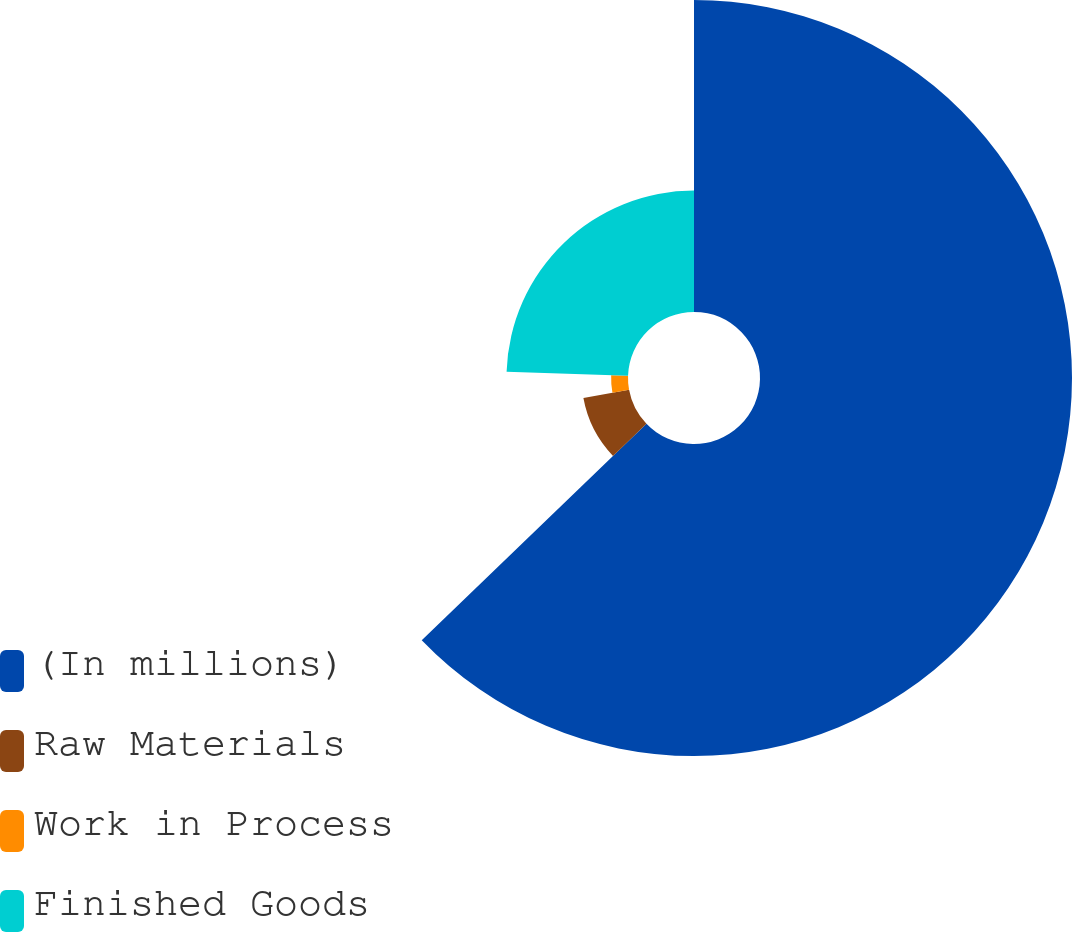<chart> <loc_0><loc_0><loc_500><loc_500><pie_chart><fcel>(In millions)<fcel>Raw Materials<fcel>Work in Process<fcel>Finished Goods<nl><fcel>62.8%<fcel>9.34%<fcel>3.4%<fcel>24.46%<nl></chart> 